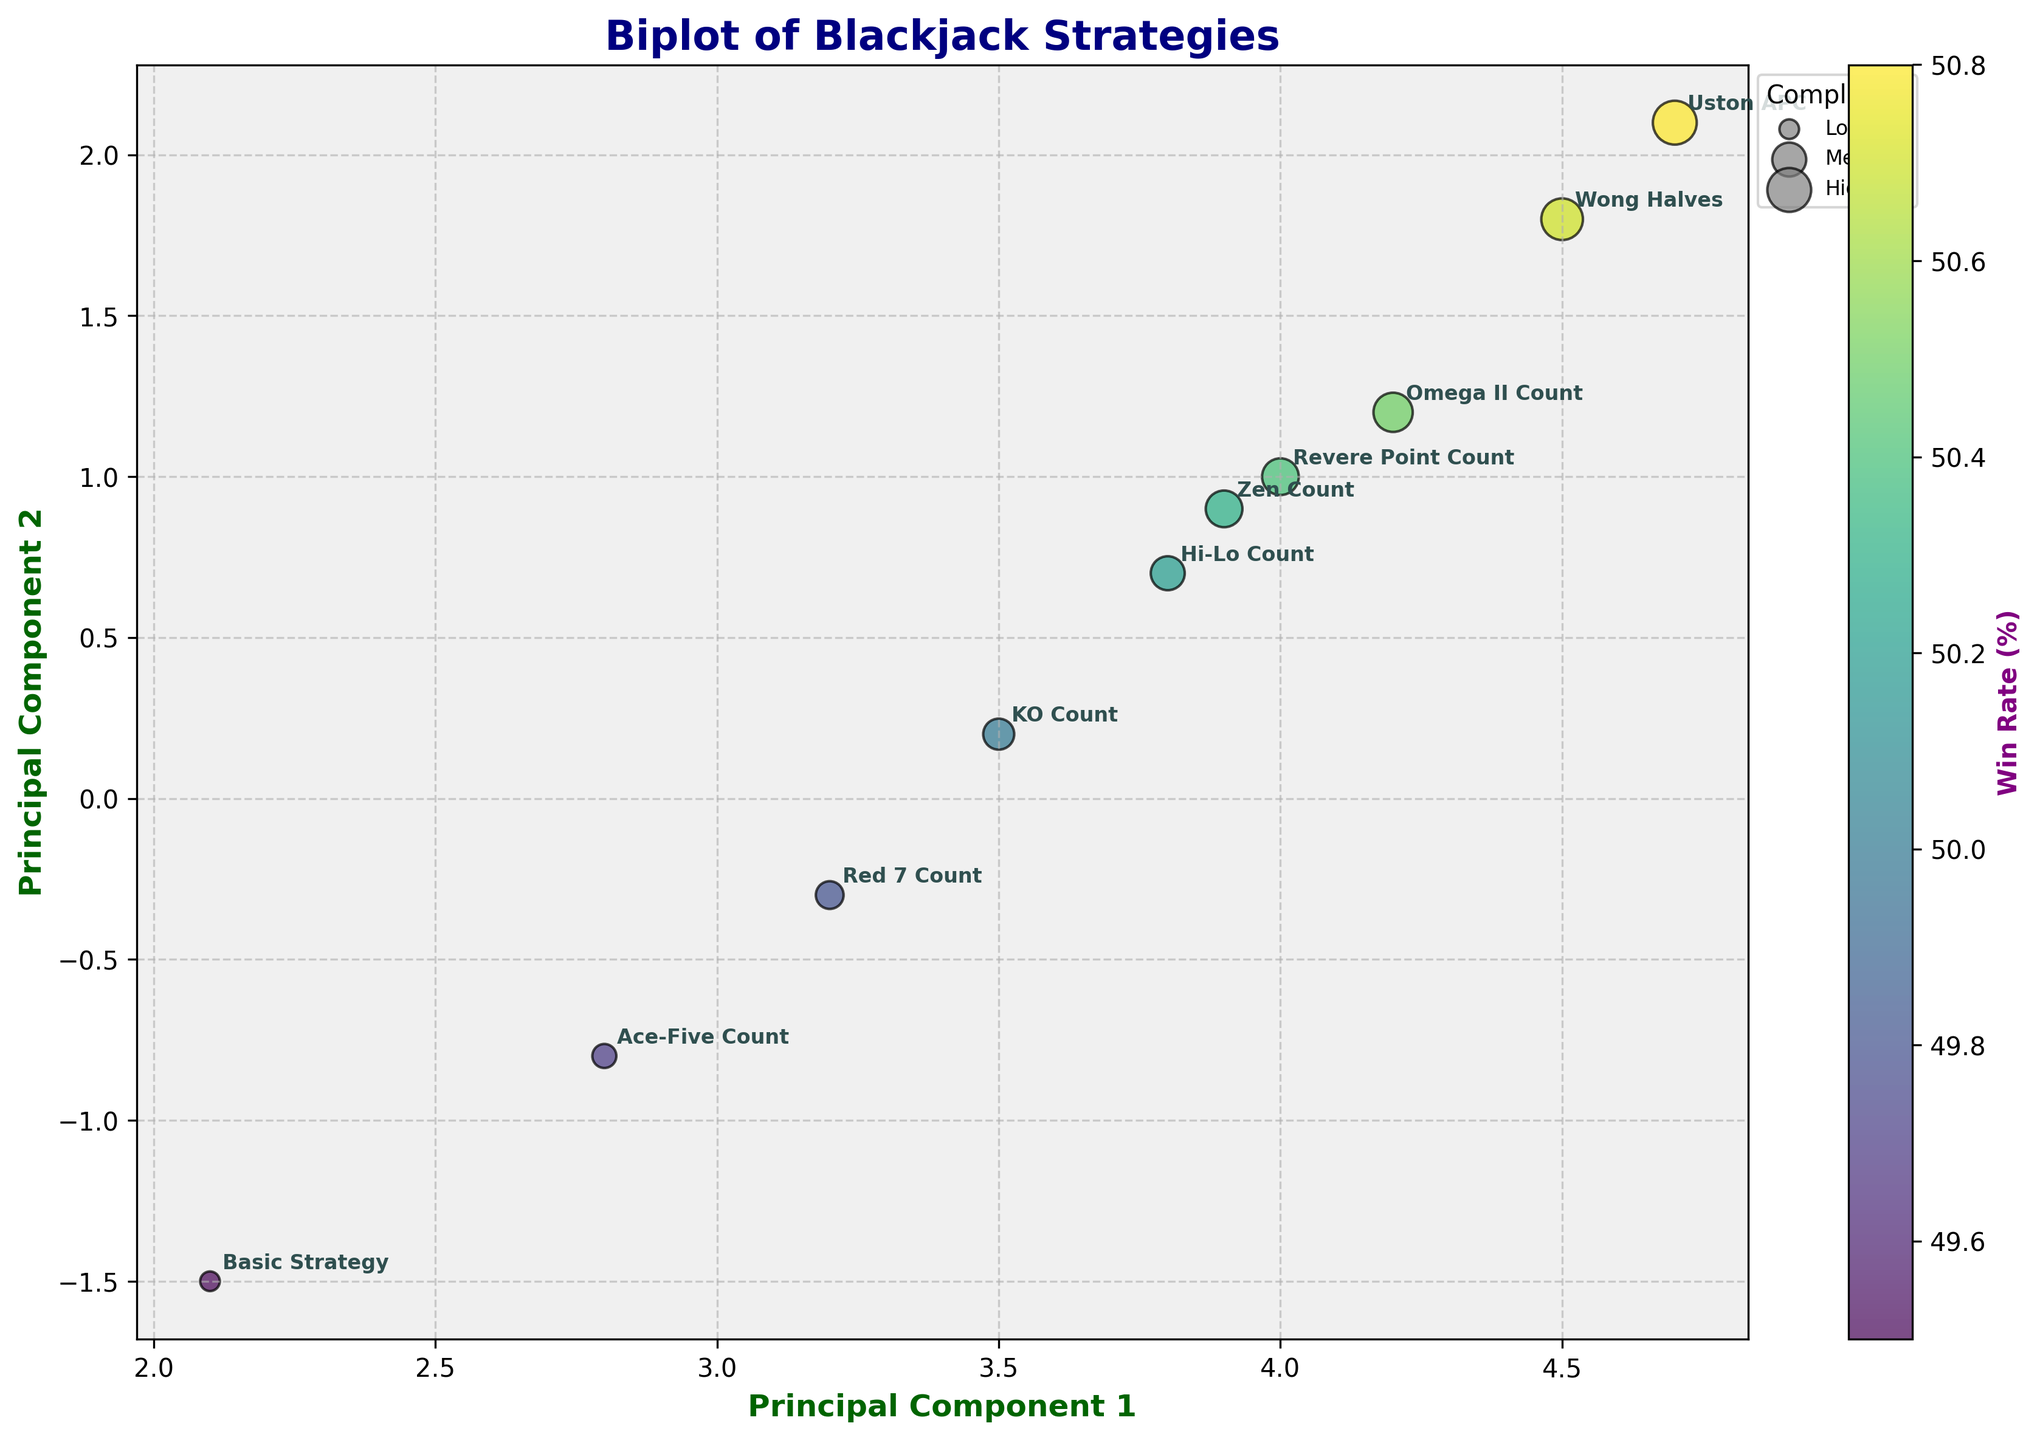What is the title of the plot? The title is located at the top center of the plot and is written in a large bold font. It is meant to give the viewer a quick understanding of what the plot represents.
Answer: Biplot of Blackjack Strategies How many different blackjack strategies are displayed in the plot? Each data point represents a different blackjack strategy, labeled with its name. Counting these labels will give us the number of strategies shown.
Answer: 10 Which strategy has the highest value along Principal Component 1? Principal Component 1 is plotted along the x-axis. The strategy with the highest x-value will have the highest PC1.
Answer: Uston APC Which strategy has the highest win rate? The win rate is represented by the color intensity. The strategy with the darkest color according to the colorbar legend will have the highest win rate.
Answer: Uston APC What are the axes labels for the plot? Axes labels are written along the x-axis and y-axis, usually in bold font to clarify what each axis represents.
Answer: Principal Component 1 (x-axis) and Principal Component 2 (y-axis) How does the complexity of the strategies vary visually in the plot? Complexity is visually indicated by the size of the data points. Larger data points represent higher complexity.
Answer: Higher complexity is shown by larger circles Which strategy appears to be the simplest to implement based on the plot's visuals? Complexity is indicated by the size of the data points. The smallest data point will represent the simplest strategy.
Answer: Basic Strategy What is the principal component score for KO Count based on the biplot? By locating KO Count on the plot and reading off its position, we can extract its PC1 and PC2 values. KO Count's coordinate (PC1, PC2) = (3.5, 0.2).
Answer: (3.5, 0.2) How do the Hi-Lo Count and Zen Count compare in terms of their principal components? Comparing their positions on the plot where Hi-Lo Count (3.8, 0.7) and Zen Count (3.9, 0.9), we can see their relative positions on PC1 and PC2.
Answer: Zen Count has slightly higher scores in both principal components Which strategy has the highest house edge reduction and what are its principal component scores? Looking at the size and color of data points and confirming with labels, Uston APC stands out. The principal component scores are observable directly from the point’s position on the plot.
Answer: Uston APC with scores (4.7, 2.1) 